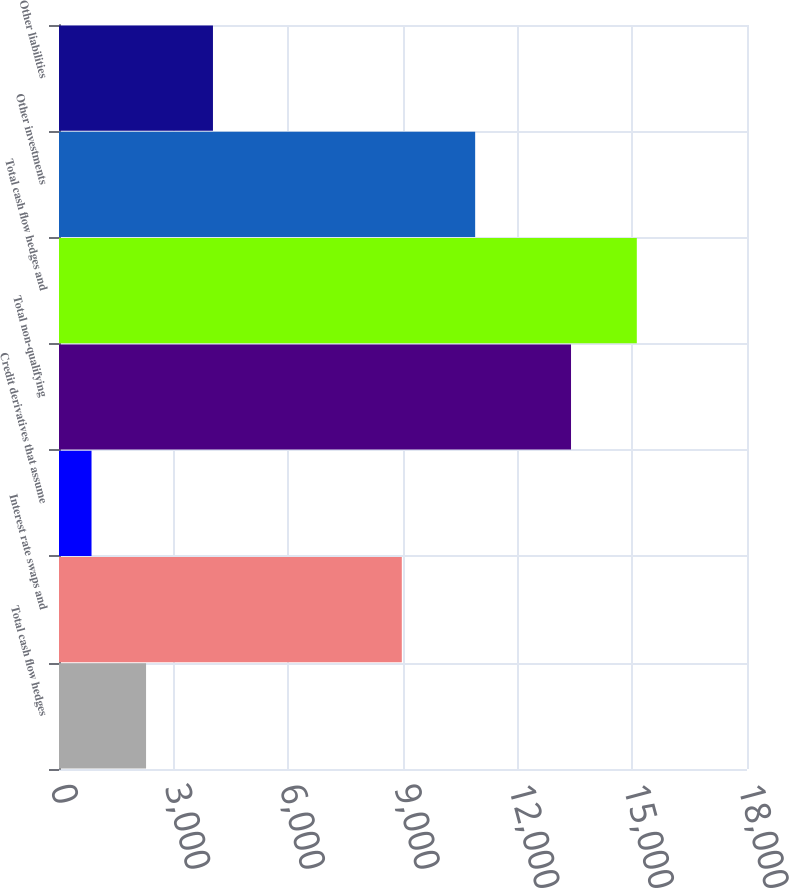<chart> <loc_0><loc_0><loc_500><loc_500><bar_chart><fcel>Total cash flow hedges<fcel>Interest rate swaps and<fcel>Credit derivatives that assume<fcel>Total non-qualifying<fcel>Total cash flow hedges and<fcel>Other investments<fcel>Other liabilities<nl><fcel>2277.6<fcel>8969<fcel>851<fcel>13396<fcel>15117<fcel>10888<fcel>4028<nl></chart> 